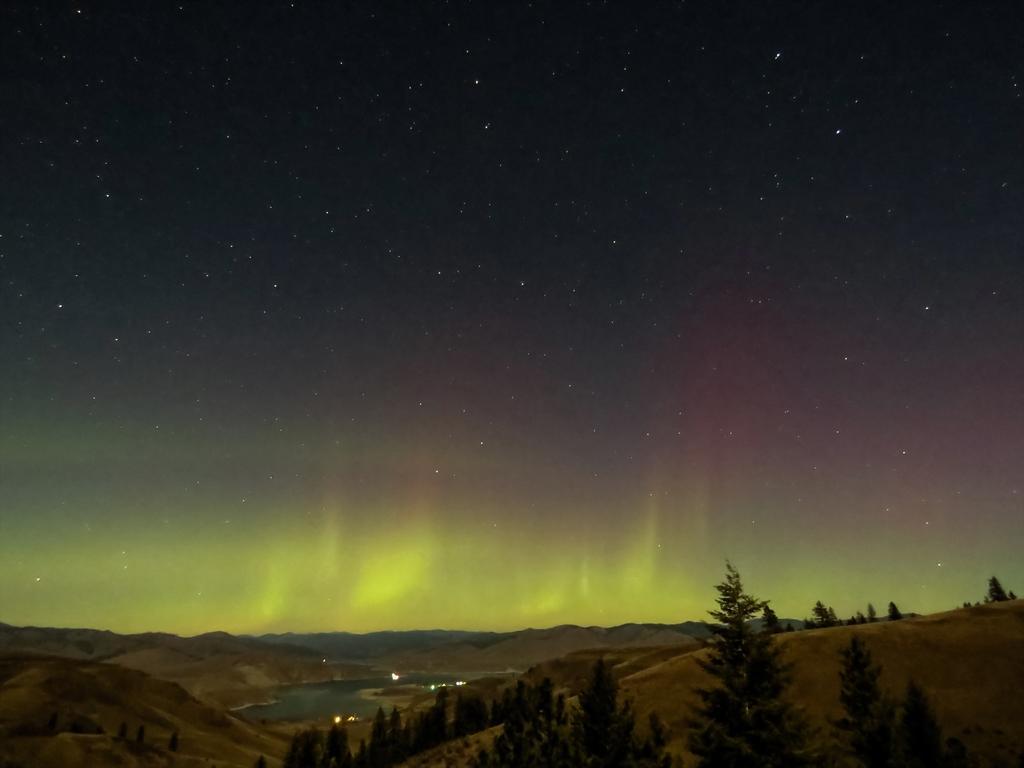Can you describe this image briefly? In this picture there are trees at the bottom side of the image and there is sky at the top side of the image. 